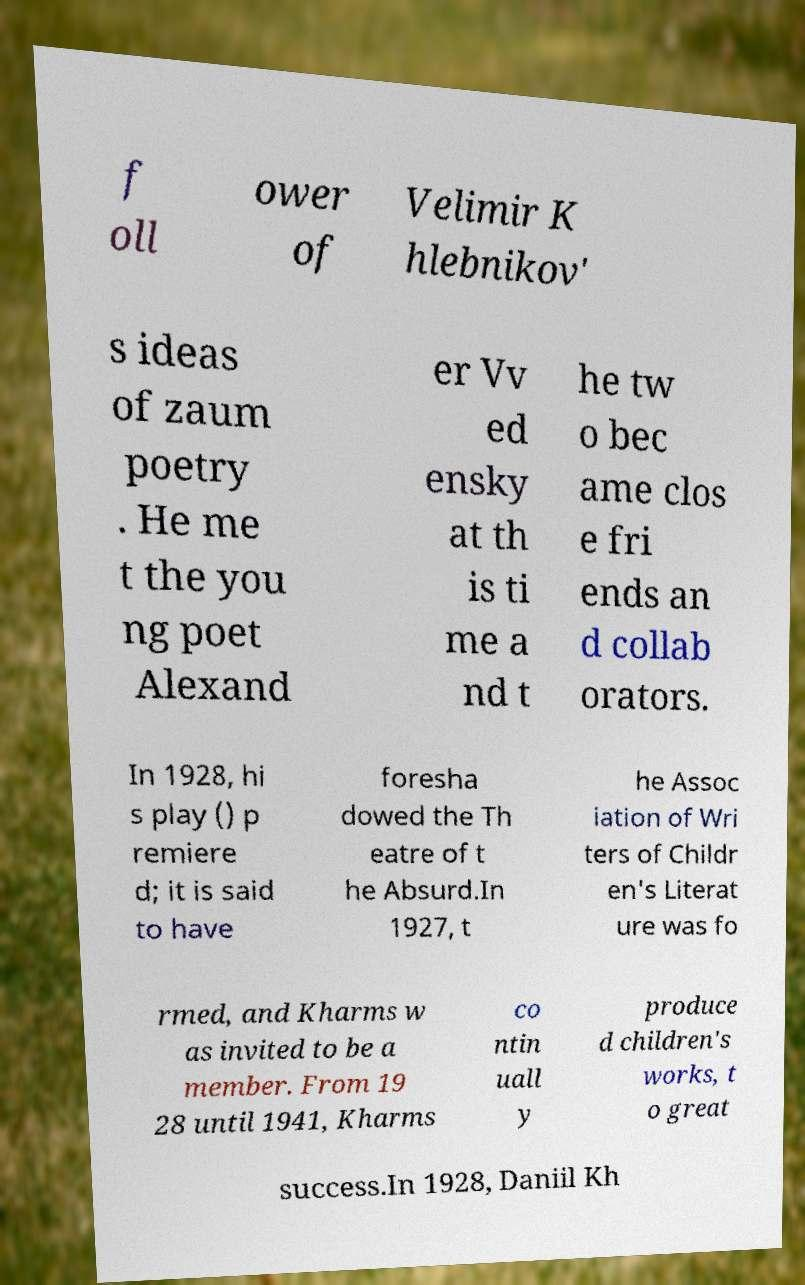What messages or text are displayed in this image? I need them in a readable, typed format. f oll ower of Velimir K hlebnikov' s ideas of zaum poetry . He me t the you ng poet Alexand er Vv ed ensky at th is ti me a nd t he tw o bec ame clos e fri ends an d collab orators. In 1928, hi s play () p remiere d; it is said to have foresha dowed the Th eatre of t he Absurd.In 1927, t he Assoc iation of Wri ters of Childr en's Literat ure was fo rmed, and Kharms w as invited to be a member. From 19 28 until 1941, Kharms co ntin uall y produce d children's works, t o great success.In 1928, Daniil Kh 